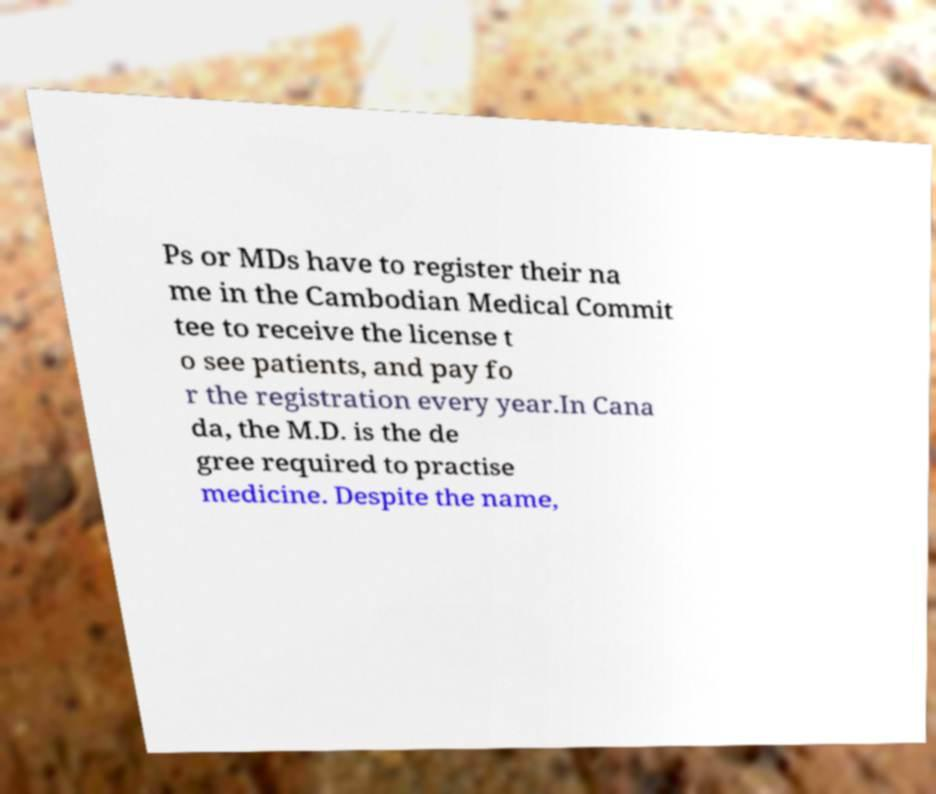Please read and relay the text visible in this image. What does it say? Ps or MDs have to register their na me in the Cambodian Medical Commit tee to receive the license t o see patients, and pay fo r the registration every year.In Cana da, the M.D. is the de gree required to practise medicine. Despite the name, 